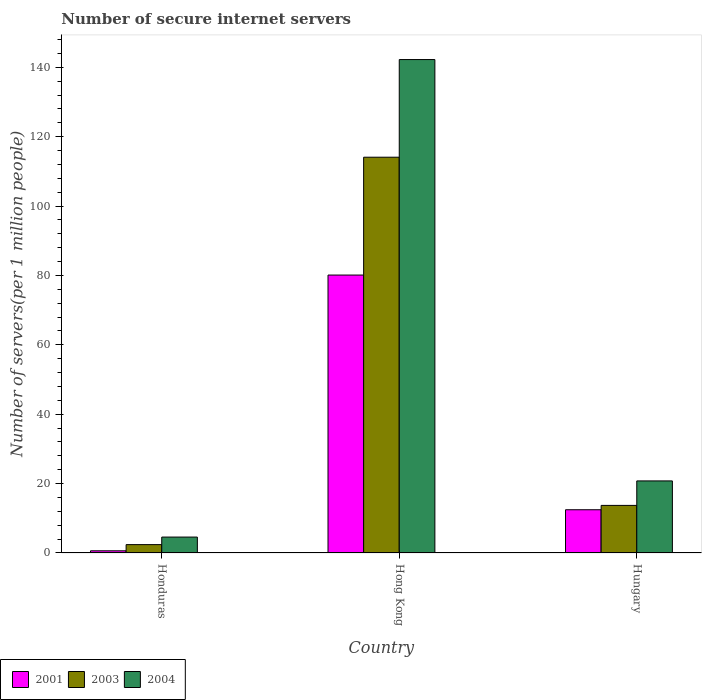Are the number of bars per tick equal to the number of legend labels?
Make the answer very short. Yes. Are the number of bars on each tick of the X-axis equal?
Offer a very short reply. Yes. How many bars are there on the 2nd tick from the left?
Offer a terse response. 3. How many bars are there on the 3rd tick from the right?
Give a very brief answer. 3. What is the label of the 2nd group of bars from the left?
Your response must be concise. Hong Kong. In how many cases, is the number of bars for a given country not equal to the number of legend labels?
Give a very brief answer. 0. What is the number of secure internet servers in 2003 in Hungary?
Make the answer very short. 13.72. Across all countries, what is the maximum number of secure internet servers in 2003?
Offer a very short reply. 114.1. Across all countries, what is the minimum number of secure internet servers in 2004?
Offer a terse response. 4.59. In which country was the number of secure internet servers in 2004 maximum?
Your answer should be very brief. Hong Kong. In which country was the number of secure internet servers in 2004 minimum?
Give a very brief answer. Honduras. What is the total number of secure internet servers in 2001 in the graph?
Your answer should be compact. 93.22. What is the difference between the number of secure internet servers in 2004 in Honduras and that in Hong Kong?
Your answer should be very brief. -137.67. What is the difference between the number of secure internet servers in 2001 in Hong Kong and the number of secure internet servers in 2003 in Honduras?
Offer a terse response. 77.71. What is the average number of secure internet servers in 2003 per country?
Provide a succinct answer. 43.41. What is the difference between the number of secure internet servers of/in 2001 and number of secure internet servers of/in 2004 in Hong Kong?
Your response must be concise. -62.13. In how many countries, is the number of secure internet servers in 2001 greater than 40?
Offer a terse response. 1. What is the ratio of the number of secure internet servers in 2001 in Honduras to that in Hungary?
Your answer should be compact. 0.05. What is the difference between the highest and the second highest number of secure internet servers in 2004?
Provide a short and direct response. 16.19. What is the difference between the highest and the lowest number of secure internet servers in 2001?
Keep it short and to the point. 79.5. In how many countries, is the number of secure internet servers in 2004 greater than the average number of secure internet servers in 2004 taken over all countries?
Your response must be concise. 1. How many bars are there?
Provide a short and direct response. 9. Are all the bars in the graph horizontal?
Make the answer very short. No. How many countries are there in the graph?
Your response must be concise. 3. Where does the legend appear in the graph?
Give a very brief answer. Bottom left. How many legend labels are there?
Ensure brevity in your answer.  3. How are the legend labels stacked?
Provide a succinct answer. Horizontal. What is the title of the graph?
Ensure brevity in your answer.  Number of secure internet servers. What is the label or title of the Y-axis?
Offer a terse response. Number of servers(per 1 million people). What is the Number of servers(per 1 million people) in 2001 in Honduras?
Provide a succinct answer. 0.63. What is the Number of servers(per 1 million people) in 2003 in Honduras?
Your response must be concise. 2.41. What is the Number of servers(per 1 million people) of 2004 in Honduras?
Offer a terse response. 4.59. What is the Number of servers(per 1 million people) in 2001 in Hong Kong?
Your response must be concise. 80.13. What is the Number of servers(per 1 million people) in 2003 in Hong Kong?
Provide a short and direct response. 114.1. What is the Number of servers(per 1 million people) of 2004 in Hong Kong?
Your response must be concise. 142.26. What is the Number of servers(per 1 million people) in 2001 in Hungary?
Make the answer very short. 12.47. What is the Number of servers(per 1 million people) in 2003 in Hungary?
Ensure brevity in your answer.  13.72. What is the Number of servers(per 1 million people) in 2004 in Hungary?
Your answer should be compact. 20.78. Across all countries, what is the maximum Number of servers(per 1 million people) in 2001?
Your answer should be compact. 80.13. Across all countries, what is the maximum Number of servers(per 1 million people) of 2003?
Offer a terse response. 114.1. Across all countries, what is the maximum Number of servers(per 1 million people) in 2004?
Offer a very short reply. 142.26. Across all countries, what is the minimum Number of servers(per 1 million people) in 2001?
Offer a very short reply. 0.63. Across all countries, what is the minimum Number of servers(per 1 million people) in 2003?
Ensure brevity in your answer.  2.41. Across all countries, what is the minimum Number of servers(per 1 million people) of 2004?
Your answer should be compact. 4.59. What is the total Number of servers(per 1 million people) of 2001 in the graph?
Offer a very short reply. 93.22. What is the total Number of servers(per 1 million people) of 2003 in the graph?
Offer a very short reply. 130.24. What is the total Number of servers(per 1 million people) in 2004 in the graph?
Keep it short and to the point. 167.62. What is the difference between the Number of servers(per 1 million people) in 2001 in Honduras and that in Hong Kong?
Your answer should be very brief. -79.5. What is the difference between the Number of servers(per 1 million people) in 2003 in Honduras and that in Hong Kong?
Offer a terse response. -111.69. What is the difference between the Number of servers(per 1 million people) of 2004 in Honduras and that in Hong Kong?
Offer a terse response. -137.67. What is the difference between the Number of servers(per 1 million people) of 2001 in Honduras and that in Hungary?
Offer a very short reply. -11.84. What is the difference between the Number of servers(per 1 million people) of 2003 in Honduras and that in Hungary?
Offer a very short reply. -11.31. What is the difference between the Number of servers(per 1 million people) of 2004 in Honduras and that in Hungary?
Provide a short and direct response. -16.19. What is the difference between the Number of servers(per 1 million people) in 2001 in Hong Kong and that in Hungary?
Offer a terse response. 67.66. What is the difference between the Number of servers(per 1 million people) in 2003 in Hong Kong and that in Hungary?
Offer a very short reply. 100.38. What is the difference between the Number of servers(per 1 million people) of 2004 in Hong Kong and that in Hungary?
Your answer should be very brief. 121.48. What is the difference between the Number of servers(per 1 million people) of 2001 in Honduras and the Number of servers(per 1 million people) of 2003 in Hong Kong?
Keep it short and to the point. -113.47. What is the difference between the Number of servers(per 1 million people) in 2001 in Honduras and the Number of servers(per 1 million people) in 2004 in Hong Kong?
Your answer should be compact. -141.63. What is the difference between the Number of servers(per 1 million people) in 2003 in Honduras and the Number of servers(per 1 million people) in 2004 in Hong Kong?
Provide a short and direct response. -139.84. What is the difference between the Number of servers(per 1 million people) in 2001 in Honduras and the Number of servers(per 1 million people) in 2003 in Hungary?
Offer a very short reply. -13.09. What is the difference between the Number of servers(per 1 million people) of 2001 in Honduras and the Number of servers(per 1 million people) of 2004 in Hungary?
Give a very brief answer. -20.15. What is the difference between the Number of servers(per 1 million people) of 2003 in Honduras and the Number of servers(per 1 million people) of 2004 in Hungary?
Make the answer very short. -18.36. What is the difference between the Number of servers(per 1 million people) in 2001 in Hong Kong and the Number of servers(per 1 million people) in 2003 in Hungary?
Offer a terse response. 66.41. What is the difference between the Number of servers(per 1 million people) of 2001 in Hong Kong and the Number of servers(per 1 million people) of 2004 in Hungary?
Your response must be concise. 59.35. What is the difference between the Number of servers(per 1 million people) of 2003 in Hong Kong and the Number of servers(per 1 million people) of 2004 in Hungary?
Give a very brief answer. 93.33. What is the average Number of servers(per 1 million people) of 2001 per country?
Provide a succinct answer. 31.07. What is the average Number of servers(per 1 million people) in 2003 per country?
Ensure brevity in your answer.  43.41. What is the average Number of servers(per 1 million people) of 2004 per country?
Your answer should be compact. 55.87. What is the difference between the Number of servers(per 1 million people) in 2001 and Number of servers(per 1 million people) in 2003 in Honduras?
Offer a terse response. -1.79. What is the difference between the Number of servers(per 1 million people) in 2001 and Number of servers(per 1 million people) in 2004 in Honduras?
Keep it short and to the point. -3.96. What is the difference between the Number of servers(per 1 million people) in 2003 and Number of servers(per 1 million people) in 2004 in Honduras?
Your response must be concise. -2.18. What is the difference between the Number of servers(per 1 million people) of 2001 and Number of servers(per 1 million people) of 2003 in Hong Kong?
Your answer should be very brief. -33.97. What is the difference between the Number of servers(per 1 million people) in 2001 and Number of servers(per 1 million people) in 2004 in Hong Kong?
Make the answer very short. -62.13. What is the difference between the Number of servers(per 1 million people) in 2003 and Number of servers(per 1 million people) in 2004 in Hong Kong?
Keep it short and to the point. -28.15. What is the difference between the Number of servers(per 1 million people) of 2001 and Number of servers(per 1 million people) of 2003 in Hungary?
Keep it short and to the point. -1.26. What is the difference between the Number of servers(per 1 million people) of 2001 and Number of servers(per 1 million people) of 2004 in Hungary?
Your answer should be compact. -8.31. What is the difference between the Number of servers(per 1 million people) in 2003 and Number of servers(per 1 million people) in 2004 in Hungary?
Give a very brief answer. -7.06. What is the ratio of the Number of servers(per 1 million people) in 2001 in Honduras to that in Hong Kong?
Offer a terse response. 0.01. What is the ratio of the Number of servers(per 1 million people) in 2003 in Honduras to that in Hong Kong?
Make the answer very short. 0.02. What is the ratio of the Number of servers(per 1 million people) of 2004 in Honduras to that in Hong Kong?
Offer a very short reply. 0.03. What is the ratio of the Number of servers(per 1 million people) of 2001 in Honduras to that in Hungary?
Keep it short and to the point. 0.05. What is the ratio of the Number of servers(per 1 million people) in 2003 in Honduras to that in Hungary?
Provide a short and direct response. 0.18. What is the ratio of the Number of servers(per 1 million people) in 2004 in Honduras to that in Hungary?
Offer a terse response. 0.22. What is the ratio of the Number of servers(per 1 million people) of 2001 in Hong Kong to that in Hungary?
Provide a short and direct response. 6.43. What is the ratio of the Number of servers(per 1 million people) in 2003 in Hong Kong to that in Hungary?
Offer a very short reply. 8.32. What is the ratio of the Number of servers(per 1 million people) of 2004 in Hong Kong to that in Hungary?
Your response must be concise. 6.85. What is the difference between the highest and the second highest Number of servers(per 1 million people) in 2001?
Provide a short and direct response. 67.66. What is the difference between the highest and the second highest Number of servers(per 1 million people) of 2003?
Make the answer very short. 100.38. What is the difference between the highest and the second highest Number of servers(per 1 million people) in 2004?
Give a very brief answer. 121.48. What is the difference between the highest and the lowest Number of servers(per 1 million people) in 2001?
Provide a short and direct response. 79.5. What is the difference between the highest and the lowest Number of servers(per 1 million people) of 2003?
Your response must be concise. 111.69. What is the difference between the highest and the lowest Number of servers(per 1 million people) of 2004?
Offer a very short reply. 137.67. 